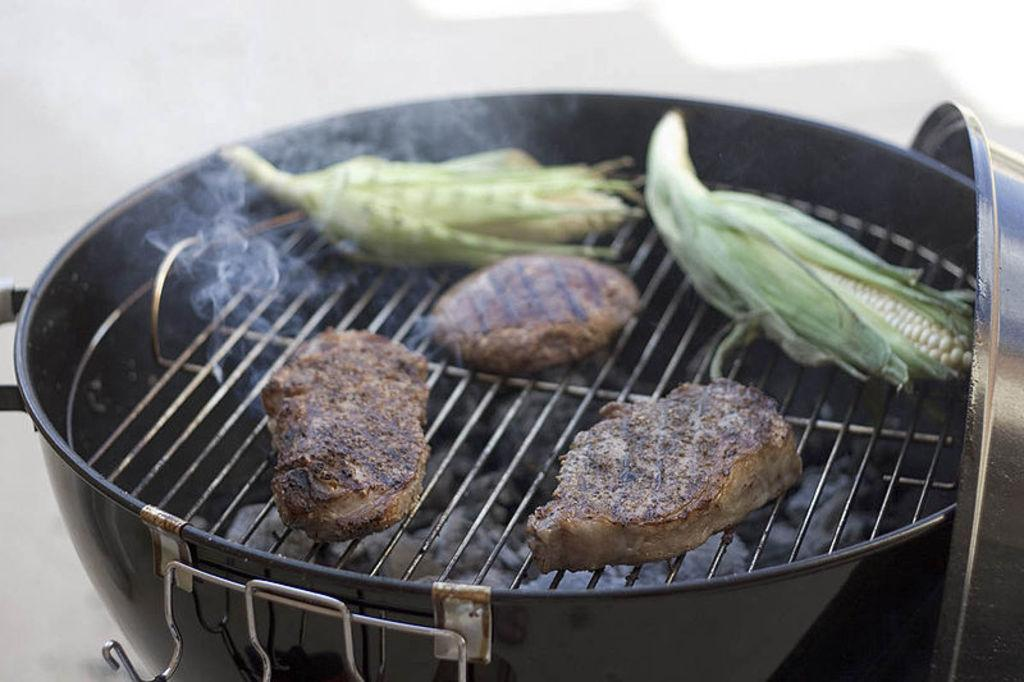What is in the pan that is visible in the image? Corn and flesh are being cooked in the pan. What is the result of cooking the corn and flesh? There is smoke in the image, which suggests that the cooking process is producing smoke. What can be seen in the background of the image? There is a wall in the background of the image. What type of shoes can be seen in the image? There are no shoes present in the image. How much butter is being used to cook the corn and flesh in the image? There is no mention of butter being used in the image; only corn and flesh are being cooked in the pan. 